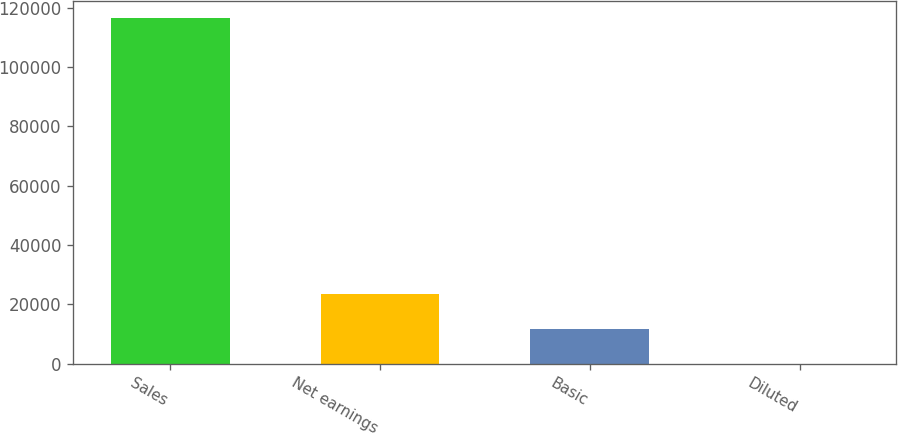Convert chart to OTSL. <chart><loc_0><loc_0><loc_500><loc_500><bar_chart><fcel>Sales<fcel>Net earnings<fcel>Basic<fcel>Diluted<nl><fcel>116491<fcel>23301.4<fcel>11652.8<fcel>4.06<nl></chart> 